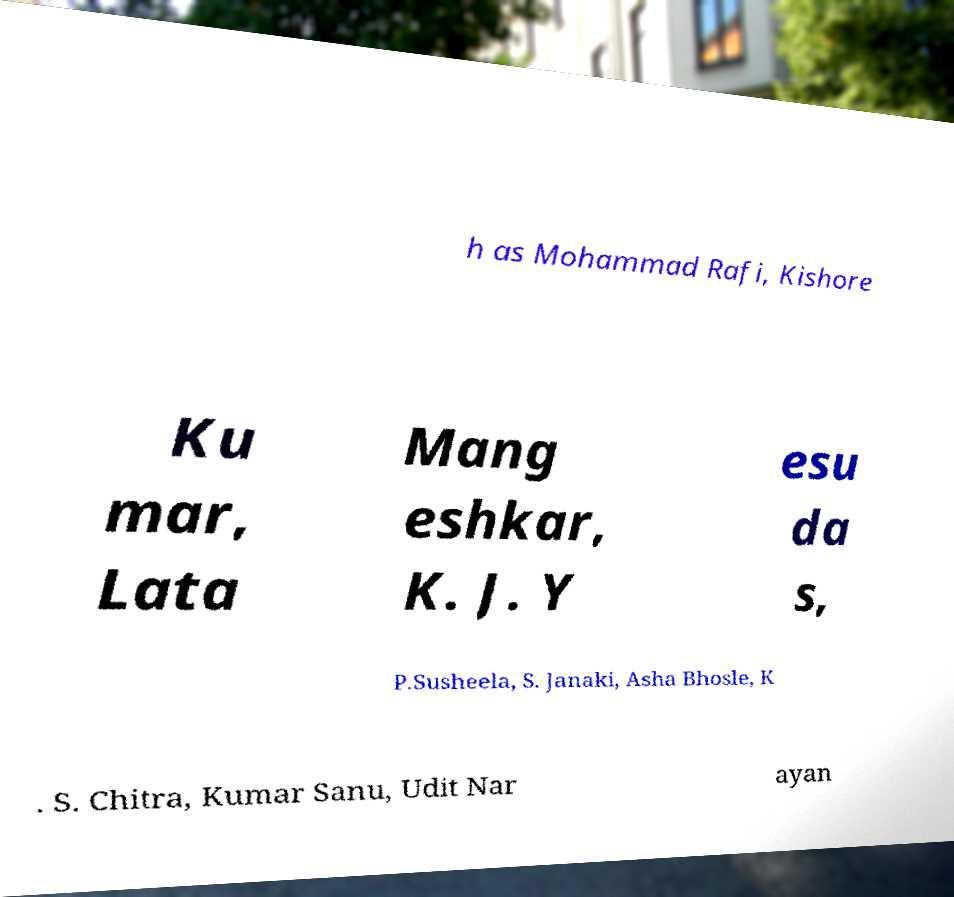Can you accurately transcribe the text from the provided image for me? h as Mohammad Rafi, Kishore Ku mar, Lata Mang eshkar, K. J. Y esu da s, P.Susheela, S. Janaki, Asha Bhosle, K . S. Chitra, Kumar Sanu, Udit Nar ayan 